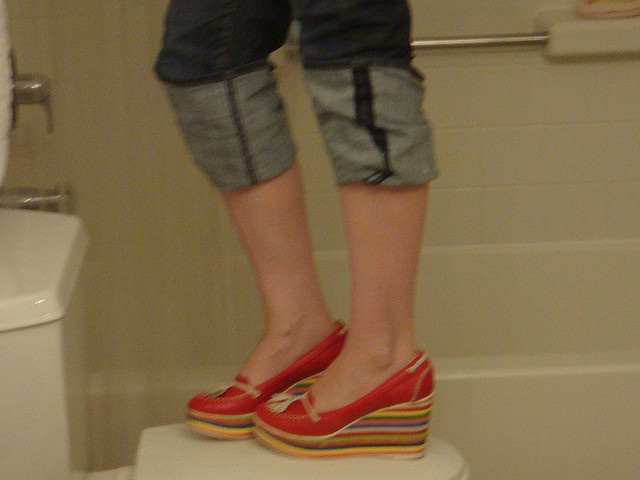Describe the objects in this image and their specific colors. I can see people in darkgray, gray, black, and brown tones, toilet in darkgray, tan, and gray tones, and toilet in darkgray, tan, gray, and olive tones in this image. 